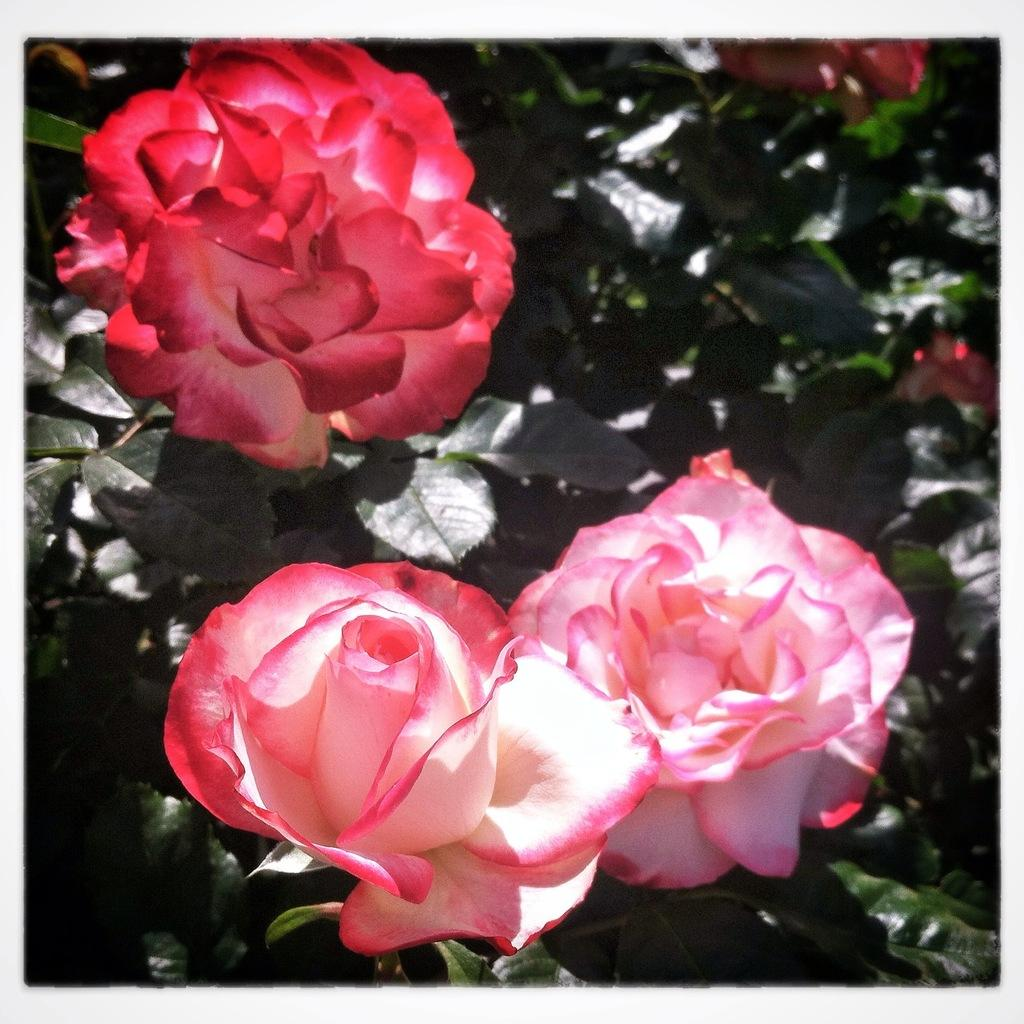How many flowers can be seen in the front of the image? There are three flowers in the front of the image. What else can be seen in the background of the image? Leaves are visible in the background of the image. What type of feather is written in the caption of the image? There is no caption present in the image, and therefore no feather can be mentioned in it. 